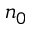Convert formula to latex. <formula><loc_0><loc_0><loc_500><loc_500>n _ { 0 }</formula> 